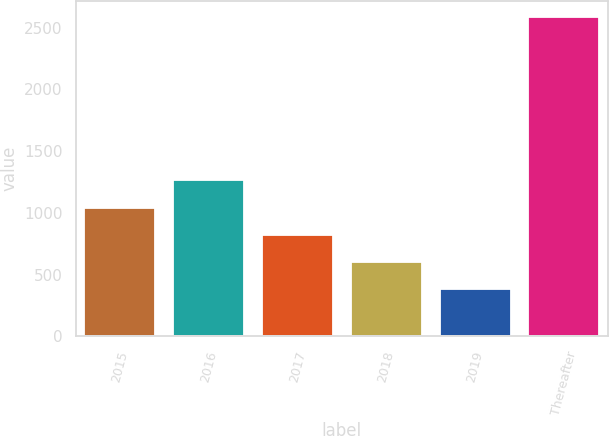Convert chart to OTSL. <chart><loc_0><loc_0><loc_500><loc_500><bar_chart><fcel>2015<fcel>2016<fcel>2017<fcel>2018<fcel>2019<fcel>Thereafter<nl><fcel>1043.8<fcel>1264.4<fcel>823.2<fcel>602.6<fcel>382<fcel>2588<nl></chart> 